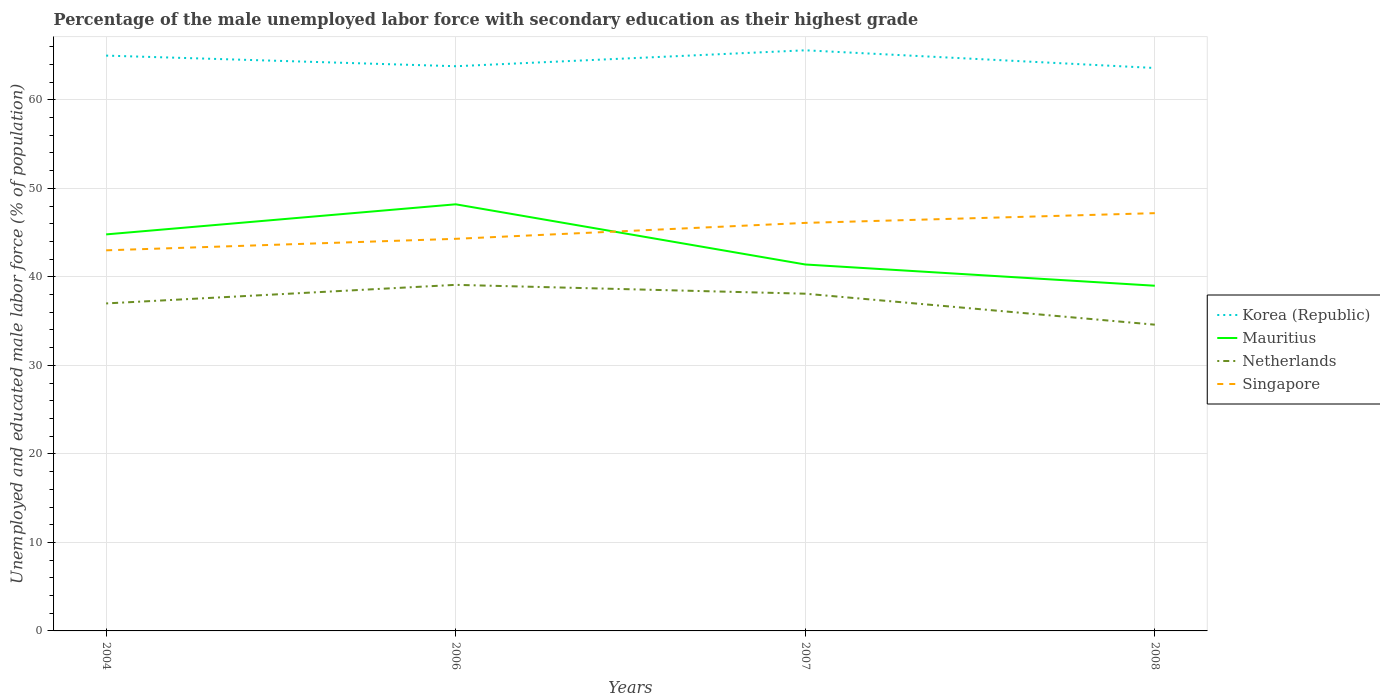How many different coloured lines are there?
Offer a terse response. 4. Does the line corresponding to Mauritius intersect with the line corresponding to Korea (Republic)?
Give a very brief answer. No. Is the number of lines equal to the number of legend labels?
Provide a succinct answer. Yes. Across all years, what is the maximum percentage of the unemployed male labor force with secondary education in Netherlands?
Offer a very short reply. 34.6. What is the total percentage of the unemployed male labor force with secondary education in Mauritius in the graph?
Your answer should be compact. 9.2. What is the difference between the highest and the second highest percentage of the unemployed male labor force with secondary education in Korea (Republic)?
Your answer should be compact. 2. What is the difference between the highest and the lowest percentage of the unemployed male labor force with secondary education in Netherlands?
Offer a terse response. 2. Is the percentage of the unemployed male labor force with secondary education in Singapore strictly greater than the percentage of the unemployed male labor force with secondary education in Netherlands over the years?
Provide a short and direct response. No. What is the difference between two consecutive major ticks on the Y-axis?
Provide a succinct answer. 10. Does the graph contain any zero values?
Offer a very short reply. No. Does the graph contain grids?
Your response must be concise. Yes. What is the title of the graph?
Your answer should be very brief. Percentage of the male unemployed labor force with secondary education as their highest grade. What is the label or title of the X-axis?
Your answer should be very brief. Years. What is the label or title of the Y-axis?
Your answer should be very brief. Unemployed and educated male labor force (% of population). What is the Unemployed and educated male labor force (% of population) in Korea (Republic) in 2004?
Offer a terse response. 65. What is the Unemployed and educated male labor force (% of population) in Mauritius in 2004?
Ensure brevity in your answer.  44.8. What is the Unemployed and educated male labor force (% of population) in Korea (Republic) in 2006?
Offer a terse response. 63.8. What is the Unemployed and educated male labor force (% of population) in Mauritius in 2006?
Keep it short and to the point. 48.2. What is the Unemployed and educated male labor force (% of population) of Netherlands in 2006?
Offer a very short reply. 39.1. What is the Unemployed and educated male labor force (% of population) of Singapore in 2006?
Your answer should be compact. 44.3. What is the Unemployed and educated male labor force (% of population) in Korea (Republic) in 2007?
Make the answer very short. 65.6. What is the Unemployed and educated male labor force (% of population) of Mauritius in 2007?
Your answer should be compact. 41.4. What is the Unemployed and educated male labor force (% of population) in Netherlands in 2007?
Provide a succinct answer. 38.1. What is the Unemployed and educated male labor force (% of population) in Singapore in 2007?
Offer a very short reply. 46.1. What is the Unemployed and educated male labor force (% of population) in Korea (Republic) in 2008?
Your answer should be compact. 63.6. What is the Unemployed and educated male labor force (% of population) in Netherlands in 2008?
Offer a terse response. 34.6. What is the Unemployed and educated male labor force (% of population) of Singapore in 2008?
Keep it short and to the point. 47.2. Across all years, what is the maximum Unemployed and educated male labor force (% of population) in Korea (Republic)?
Provide a succinct answer. 65.6. Across all years, what is the maximum Unemployed and educated male labor force (% of population) of Mauritius?
Your answer should be compact. 48.2. Across all years, what is the maximum Unemployed and educated male labor force (% of population) in Netherlands?
Give a very brief answer. 39.1. Across all years, what is the maximum Unemployed and educated male labor force (% of population) of Singapore?
Give a very brief answer. 47.2. Across all years, what is the minimum Unemployed and educated male labor force (% of population) of Korea (Republic)?
Keep it short and to the point. 63.6. Across all years, what is the minimum Unemployed and educated male labor force (% of population) in Mauritius?
Your response must be concise. 39. Across all years, what is the minimum Unemployed and educated male labor force (% of population) of Netherlands?
Offer a terse response. 34.6. What is the total Unemployed and educated male labor force (% of population) in Korea (Republic) in the graph?
Make the answer very short. 258. What is the total Unemployed and educated male labor force (% of population) of Mauritius in the graph?
Ensure brevity in your answer.  173.4. What is the total Unemployed and educated male labor force (% of population) in Netherlands in the graph?
Your answer should be compact. 148.8. What is the total Unemployed and educated male labor force (% of population) in Singapore in the graph?
Your response must be concise. 180.6. What is the difference between the Unemployed and educated male labor force (% of population) of Mauritius in 2004 and that in 2007?
Provide a succinct answer. 3.4. What is the difference between the Unemployed and educated male labor force (% of population) in Singapore in 2004 and that in 2007?
Offer a very short reply. -3.1. What is the difference between the Unemployed and educated male labor force (% of population) of Korea (Republic) in 2006 and that in 2007?
Make the answer very short. -1.8. What is the difference between the Unemployed and educated male labor force (% of population) in Netherlands in 2006 and that in 2007?
Offer a terse response. 1. What is the difference between the Unemployed and educated male labor force (% of population) in Singapore in 2006 and that in 2007?
Your answer should be compact. -1.8. What is the difference between the Unemployed and educated male labor force (% of population) in Mauritius in 2006 and that in 2008?
Provide a short and direct response. 9.2. What is the difference between the Unemployed and educated male labor force (% of population) in Netherlands in 2006 and that in 2008?
Your answer should be compact. 4.5. What is the difference between the Unemployed and educated male labor force (% of population) in Korea (Republic) in 2007 and that in 2008?
Provide a succinct answer. 2. What is the difference between the Unemployed and educated male labor force (% of population) in Singapore in 2007 and that in 2008?
Make the answer very short. -1.1. What is the difference between the Unemployed and educated male labor force (% of population) in Korea (Republic) in 2004 and the Unemployed and educated male labor force (% of population) in Netherlands in 2006?
Give a very brief answer. 25.9. What is the difference between the Unemployed and educated male labor force (% of population) in Korea (Republic) in 2004 and the Unemployed and educated male labor force (% of population) in Singapore in 2006?
Your answer should be compact. 20.7. What is the difference between the Unemployed and educated male labor force (% of population) in Mauritius in 2004 and the Unemployed and educated male labor force (% of population) in Netherlands in 2006?
Offer a very short reply. 5.7. What is the difference between the Unemployed and educated male labor force (% of population) in Korea (Republic) in 2004 and the Unemployed and educated male labor force (% of population) in Mauritius in 2007?
Your answer should be very brief. 23.6. What is the difference between the Unemployed and educated male labor force (% of population) in Korea (Republic) in 2004 and the Unemployed and educated male labor force (% of population) in Netherlands in 2007?
Give a very brief answer. 26.9. What is the difference between the Unemployed and educated male labor force (% of population) of Korea (Republic) in 2004 and the Unemployed and educated male labor force (% of population) of Singapore in 2007?
Ensure brevity in your answer.  18.9. What is the difference between the Unemployed and educated male labor force (% of population) of Netherlands in 2004 and the Unemployed and educated male labor force (% of population) of Singapore in 2007?
Provide a short and direct response. -9.1. What is the difference between the Unemployed and educated male labor force (% of population) in Korea (Republic) in 2004 and the Unemployed and educated male labor force (% of population) in Mauritius in 2008?
Provide a short and direct response. 26. What is the difference between the Unemployed and educated male labor force (% of population) of Korea (Republic) in 2004 and the Unemployed and educated male labor force (% of population) of Netherlands in 2008?
Offer a very short reply. 30.4. What is the difference between the Unemployed and educated male labor force (% of population) in Korea (Republic) in 2004 and the Unemployed and educated male labor force (% of population) in Singapore in 2008?
Your answer should be very brief. 17.8. What is the difference between the Unemployed and educated male labor force (% of population) of Mauritius in 2004 and the Unemployed and educated male labor force (% of population) of Netherlands in 2008?
Give a very brief answer. 10.2. What is the difference between the Unemployed and educated male labor force (% of population) of Netherlands in 2004 and the Unemployed and educated male labor force (% of population) of Singapore in 2008?
Provide a succinct answer. -10.2. What is the difference between the Unemployed and educated male labor force (% of population) of Korea (Republic) in 2006 and the Unemployed and educated male labor force (% of population) of Mauritius in 2007?
Your response must be concise. 22.4. What is the difference between the Unemployed and educated male labor force (% of population) of Korea (Republic) in 2006 and the Unemployed and educated male labor force (% of population) of Netherlands in 2007?
Keep it short and to the point. 25.7. What is the difference between the Unemployed and educated male labor force (% of population) of Korea (Republic) in 2006 and the Unemployed and educated male labor force (% of population) of Singapore in 2007?
Your response must be concise. 17.7. What is the difference between the Unemployed and educated male labor force (% of population) in Mauritius in 2006 and the Unemployed and educated male labor force (% of population) in Singapore in 2007?
Offer a terse response. 2.1. What is the difference between the Unemployed and educated male labor force (% of population) in Netherlands in 2006 and the Unemployed and educated male labor force (% of population) in Singapore in 2007?
Keep it short and to the point. -7. What is the difference between the Unemployed and educated male labor force (% of population) in Korea (Republic) in 2006 and the Unemployed and educated male labor force (% of population) in Mauritius in 2008?
Make the answer very short. 24.8. What is the difference between the Unemployed and educated male labor force (% of population) in Korea (Republic) in 2006 and the Unemployed and educated male labor force (% of population) in Netherlands in 2008?
Your answer should be compact. 29.2. What is the difference between the Unemployed and educated male labor force (% of population) of Korea (Republic) in 2006 and the Unemployed and educated male labor force (% of population) of Singapore in 2008?
Make the answer very short. 16.6. What is the difference between the Unemployed and educated male labor force (% of population) of Mauritius in 2006 and the Unemployed and educated male labor force (% of population) of Netherlands in 2008?
Provide a short and direct response. 13.6. What is the difference between the Unemployed and educated male labor force (% of population) of Netherlands in 2006 and the Unemployed and educated male labor force (% of population) of Singapore in 2008?
Ensure brevity in your answer.  -8.1. What is the difference between the Unemployed and educated male labor force (% of population) in Korea (Republic) in 2007 and the Unemployed and educated male labor force (% of population) in Mauritius in 2008?
Your response must be concise. 26.6. What is the average Unemployed and educated male labor force (% of population) of Korea (Republic) per year?
Ensure brevity in your answer.  64.5. What is the average Unemployed and educated male labor force (% of population) in Mauritius per year?
Give a very brief answer. 43.35. What is the average Unemployed and educated male labor force (% of population) in Netherlands per year?
Provide a succinct answer. 37.2. What is the average Unemployed and educated male labor force (% of population) of Singapore per year?
Make the answer very short. 45.15. In the year 2004, what is the difference between the Unemployed and educated male labor force (% of population) in Korea (Republic) and Unemployed and educated male labor force (% of population) in Mauritius?
Provide a succinct answer. 20.2. In the year 2004, what is the difference between the Unemployed and educated male labor force (% of population) of Korea (Republic) and Unemployed and educated male labor force (% of population) of Netherlands?
Keep it short and to the point. 28. In the year 2004, what is the difference between the Unemployed and educated male labor force (% of population) in Mauritius and Unemployed and educated male labor force (% of population) in Netherlands?
Give a very brief answer. 7.8. In the year 2004, what is the difference between the Unemployed and educated male labor force (% of population) in Netherlands and Unemployed and educated male labor force (% of population) in Singapore?
Make the answer very short. -6. In the year 2006, what is the difference between the Unemployed and educated male labor force (% of population) in Korea (Republic) and Unemployed and educated male labor force (% of population) in Mauritius?
Your answer should be compact. 15.6. In the year 2006, what is the difference between the Unemployed and educated male labor force (% of population) in Korea (Republic) and Unemployed and educated male labor force (% of population) in Netherlands?
Provide a short and direct response. 24.7. In the year 2007, what is the difference between the Unemployed and educated male labor force (% of population) in Korea (Republic) and Unemployed and educated male labor force (% of population) in Mauritius?
Offer a terse response. 24.2. In the year 2007, what is the difference between the Unemployed and educated male labor force (% of population) in Korea (Republic) and Unemployed and educated male labor force (% of population) in Netherlands?
Keep it short and to the point. 27.5. In the year 2007, what is the difference between the Unemployed and educated male labor force (% of population) in Korea (Republic) and Unemployed and educated male labor force (% of population) in Singapore?
Offer a terse response. 19.5. In the year 2007, what is the difference between the Unemployed and educated male labor force (% of population) of Mauritius and Unemployed and educated male labor force (% of population) of Singapore?
Your answer should be compact. -4.7. In the year 2007, what is the difference between the Unemployed and educated male labor force (% of population) of Netherlands and Unemployed and educated male labor force (% of population) of Singapore?
Your answer should be very brief. -8. In the year 2008, what is the difference between the Unemployed and educated male labor force (% of population) of Korea (Republic) and Unemployed and educated male labor force (% of population) of Mauritius?
Ensure brevity in your answer.  24.6. What is the ratio of the Unemployed and educated male labor force (% of population) in Korea (Republic) in 2004 to that in 2006?
Offer a very short reply. 1.02. What is the ratio of the Unemployed and educated male labor force (% of population) in Mauritius in 2004 to that in 2006?
Your answer should be very brief. 0.93. What is the ratio of the Unemployed and educated male labor force (% of population) of Netherlands in 2004 to that in 2006?
Keep it short and to the point. 0.95. What is the ratio of the Unemployed and educated male labor force (% of population) in Singapore in 2004 to that in 2006?
Offer a very short reply. 0.97. What is the ratio of the Unemployed and educated male labor force (% of population) of Korea (Republic) in 2004 to that in 2007?
Your answer should be very brief. 0.99. What is the ratio of the Unemployed and educated male labor force (% of population) of Mauritius in 2004 to that in 2007?
Offer a terse response. 1.08. What is the ratio of the Unemployed and educated male labor force (% of population) in Netherlands in 2004 to that in 2007?
Provide a short and direct response. 0.97. What is the ratio of the Unemployed and educated male labor force (% of population) of Singapore in 2004 to that in 2007?
Your response must be concise. 0.93. What is the ratio of the Unemployed and educated male labor force (% of population) in Mauritius in 2004 to that in 2008?
Give a very brief answer. 1.15. What is the ratio of the Unemployed and educated male labor force (% of population) in Netherlands in 2004 to that in 2008?
Give a very brief answer. 1.07. What is the ratio of the Unemployed and educated male labor force (% of population) of Singapore in 2004 to that in 2008?
Keep it short and to the point. 0.91. What is the ratio of the Unemployed and educated male labor force (% of population) of Korea (Republic) in 2006 to that in 2007?
Offer a very short reply. 0.97. What is the ratio of the Unemployed and educated male labor force (% of population) in Mauritius in 2006 to that in 2007?
Provide a short and direct response. 1.16. What is the ratio of the Unemployed and educated male labor force (% of population) in Netherlands in 2006 to that in 2007?
Offer a very short reply. 1.03. What is the ratio of the Unemployed and educated male labor force (% of population) in Singapore in 2006 to that in 2007?
Keep it short and to the point. 0.96. What is the ratio of the Unemployed and educated male labor force (% of population) in Korea (Republic) in 2006 to that in 2008?
Your answer should be very brief. 1. What is the ratio of the Unemployed and educated male labor force (% of population) of Mauritius in 2006 to that in 2008?
Your answer should be very brief. 1.24. What is the ratio of the Unemployed and educated male labor force (% of population) in Netherlands in 2006 to that in 2008?
Provide a succinct answer. 1.13. What is the ratio of the Unemployed and educated male labor force (% of population) in Singapore in 2006 to that in 2008?
Keep it short and to the point. 0.94. What is the ratio of the Unemployed and educated male labor force (% of population) in Korea (Republic) in 2007 to that in 2008?
Ensure brevity in your answer.  1.03. What is the ratio of the Unemployed and educated male labor force (% of population) in Mauritius in 2007 to that in 2008?
Give a very brief answer. 1.06. What is the ratio of the Unemployed and educated male labor force (% of population) of Netherlands in 2007 to that in 2008?
Give a very brief answer. 1.1. What is the ratio of the Unemployed and educated male labor force (% of population) in Singapore in 2007 to that in 2008?
Provide a succinct answer. 0.98. What is the difference between the highest and the second highest Unemployed and educated male labor force (% of population) in Korea (Republic)?
Give a very brief answer. 0.6. What is the difference between the highest and the second highest Unemployed and educated male labor force (% of population) of Netherlands?
Your answer should be compact. 1. What is the difference between the highest and the second highest Unemployed and educated male labor force (% of population) of Singapore?
Your response must be concise. 1.1. What is the difference between the highest and the lowest Unemployed and educated male labor force (% of population) in Mauritius?
Keep it short and to the point. 9.2. What is the difference between the highest and the lowest Unemployed and educated male labor force (% of population) in Netherlands?
Your answer should be compact. 4.5. What is the difference between the highest and the lowest Unemployed and educated male labor force (% of population) of Singapore?
Offer a very short reply. 4.2. 